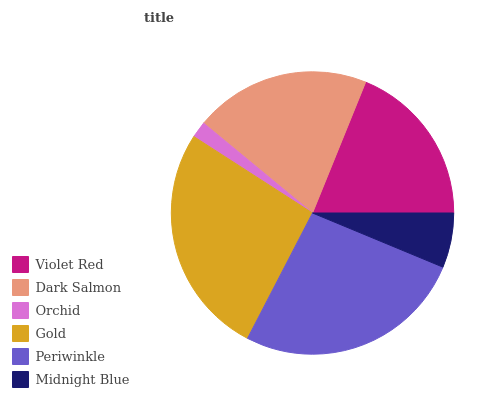Is Orchid the minimum?
Answer yes or no. Yes. Is Gold the maximum?
Answer yes or no. Yes. Is Dark Salmon the minimum?
Answer yes or no. No. Is Dark Salmon the maximum?
Answer yes or no. No. Is Dark Salmon greater than Violet Red?
Answer yes or no. Yes. Is Violet Red less than Dark Salmon?
Answer yes or no. Yes. Is Violet Red greater than Dark Salmon?
Answer yes or no. No. Is Dark Salmon less than Violet Red?
Answer yes or no. No. Is Dark Salmon the high median?
Answer yes or no. Yes. Is Violet Red the low median?
Answer yes or no. Yes. Is Orchid the high median?
Answer yes or no. No. Is Midnight Blue the low median?
Answer yes or no. No. 